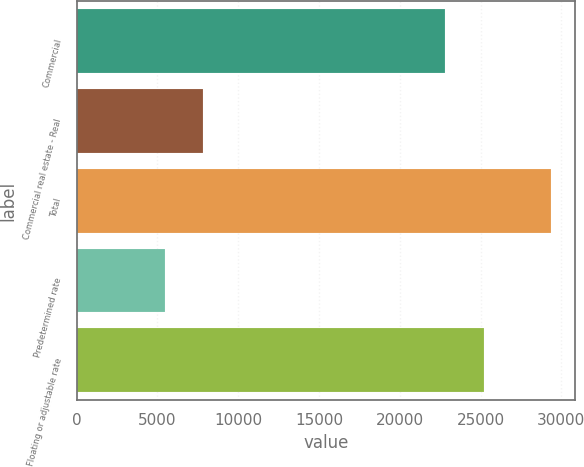Convert chart to OTSL. <chart><loc_0><loc_0><loc_500><loc_500><bar_chart><fcel>Commercial<fcel>Commercial real estate - Real<fcel>Total<fcel>Predetermined rate<fcel>Floating or adjustable rate<nl><fcel>22804<fcel>7850.1<fcel>29379<fcel>5458<fcel>25196.1<nl></chart> 